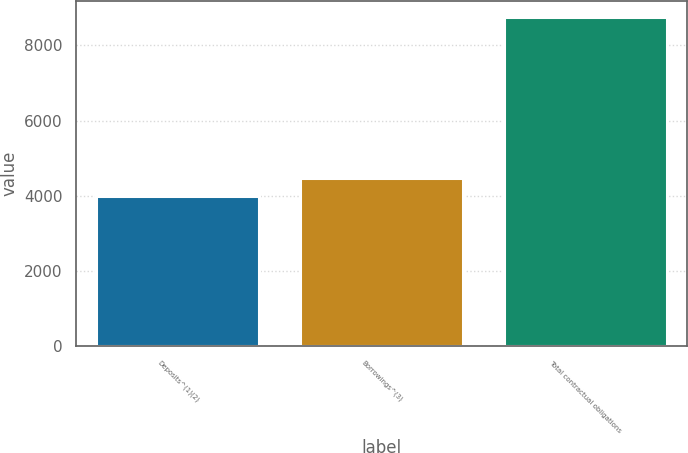Convert chart to OTSL. <chart><loc_0><loc_0><loc_500><loc_500><bar_chart><fcel>Deposits^(1)(2)<fcel>Borrowings^(3)<fcel>Total contractual obligations<nl><fcel>4005<fcel>4478.8<fcel>8743<nl></chart> 